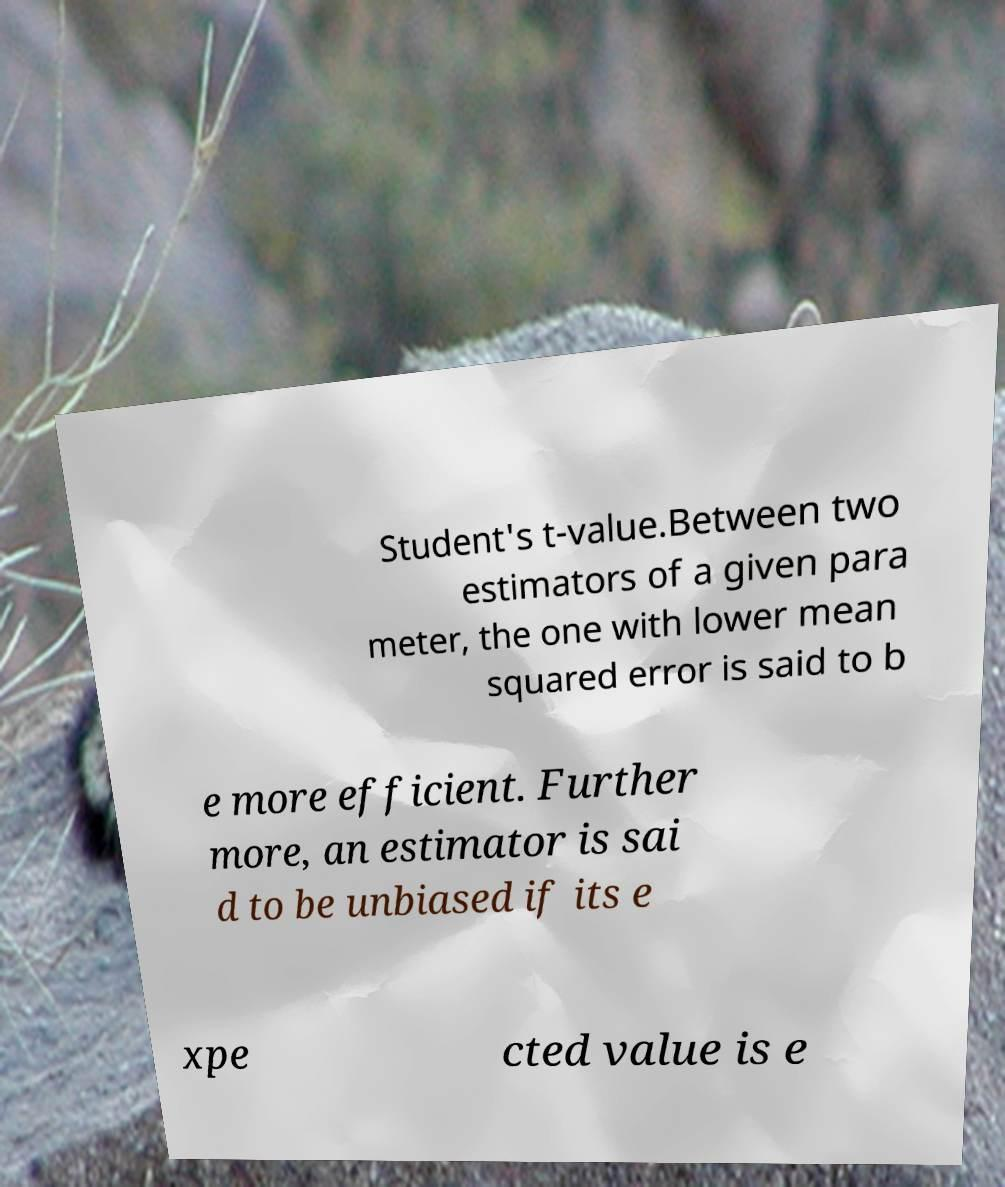For documentation purposes, I need the text within this image transcribed. Could you provide that? Student's t-value.Between two estimators of a given para meter, the one with lower mean squared error is said to b e more efficient. Further more, an estimator is sai d to be unbiased if its e xpe cted value is e 